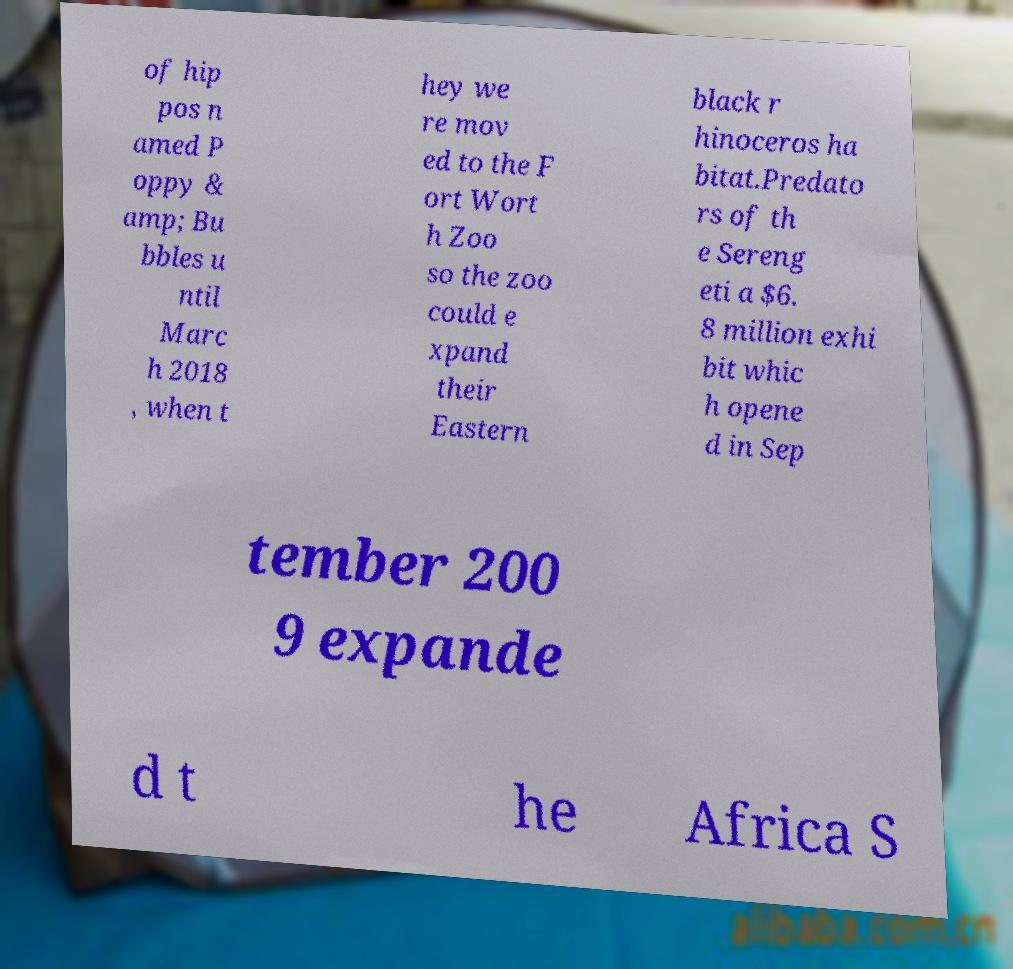I need the written content from this picture converted into text. Can you do that? of hip pos n amed P oppy & amp; Bu bbles u ntil Marc h 2018 , when t hey we re mov ed to the F ort Wort h Zoo so the zoo could e xpand their Eastern black r hinoceros ha bitat.Predato rs of th e Sereng eti a $6. 8 million exhi bit whic h opene d in Sep tember 200 9 expande d t he Africa S 